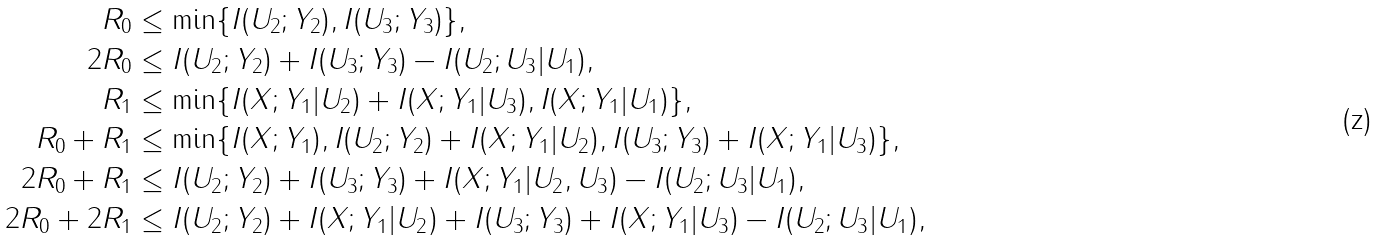<formula> <loc_0><loc_0><loc_500><loc_500>R _ { 0 } & \leq \min \{ I ( U _ { 2 } ; Y _ { 2 } ) , I ( U _ { 3 } ; Y _ { 3 } ) \} , \\ 2 R _ { 0 } & \leq I ( U _ { 2 } ; Y _ { 2 } ) + I ( U _ { 3 } ; Y _ { 3 } ) - I ( U _ { 2 } ; U _ { 3 } | U _ { 1 } ) , \\ R _ { 1 } & \leq \min \{ I ( X ; Y _ { 1 } | U _ { 2 } ) + I ( X ; Y _ { 1 } | U _ { 3 } ) , I ( X ; Y _ { 1 } | U _ { 1 } ) \} , \\ R _ { 0 } + R _ { 1 } & \leq \min \{ I ( X ; Y _ { 1 } ) , I ( U _ { 2 } ; Y _ { 2 } ) + I ( X ; Y _ { 1 } | U _ { 2 } ) , I ( U _ { 3 } ; Y _ { 3 } ) + I ( X ; Y _ { 1 } | U _ { 3 } ) \} , \\ 2 R _ { 0 } + R _ { 1 } & \leq I ( U _ { 2 } ; Y _ { 2 } ) + I ( U _ { 3 } ; Y _ { 3 } ) + I ( X ; Y _ { 1 } | U _ { 2 } , U _ { 3 } ) - I ( U _ { 2 } ; U _ { 3 } | U _ { 1 } ) , \\ 2 R _ { 0 } + 2 R _ { 1 } & \leq I ( U _ { 2 } ; Y _ { 2 } ) + I ( X ; Y _ { 1 } | U _ { 2 } ) + I ( U _ { 3 } ; Y _ { 3 } ) + I ( X ; Y _ { 1 } | U _ { 3 } ) - I ( U _ { 2 } ; U _ { 3 } | U _ { 1 } ) ,</formula> 